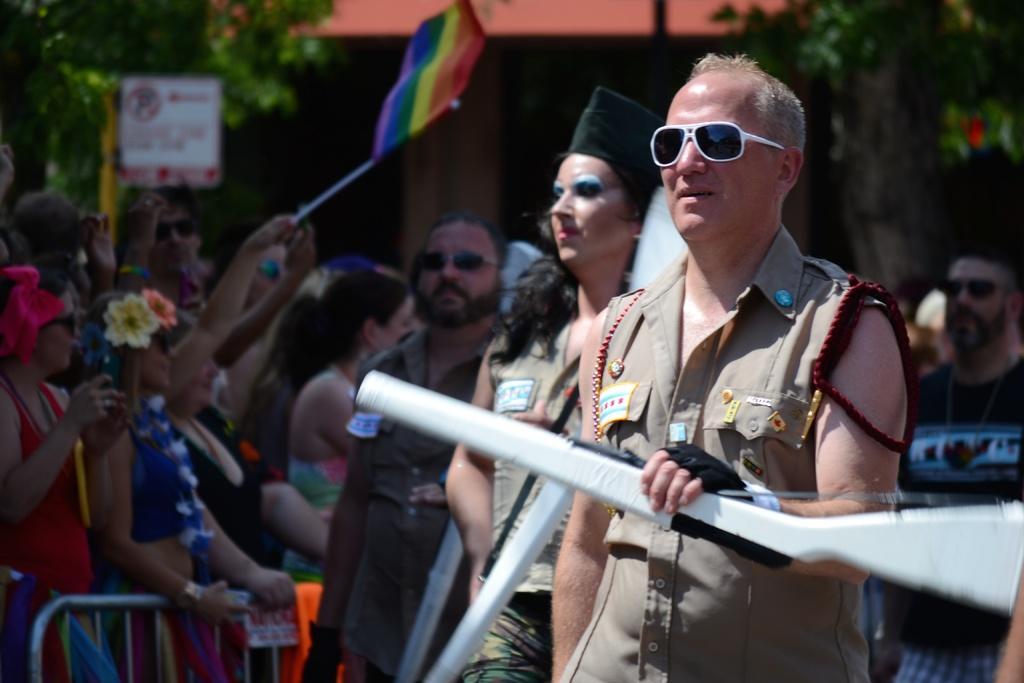Describe this image in one or two sentences. In this picture there are people, among them few people holding guns and we can see fence. In the background of the image there is a person holding a flag and we can see board on pole, trees and roof top. 